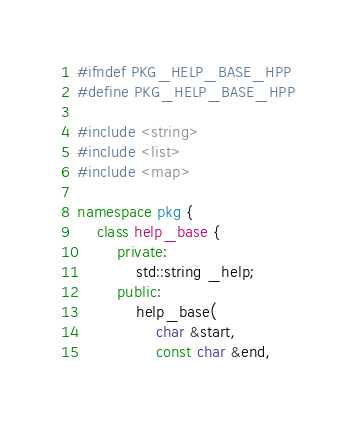Convert code to text. <code><loc_0><loc_0><loc_500><loc_500><_C++_>#ifndef PKG_HELP_BASE_HPP
#define PKG_HELP_BASE_HPP

#include <string>
#include <list>
#include <map>

namespace pkg {
    class help_base {
        private:
            std::string _help;
        public:
            help_base(
                char &start, 
                const char &end, </code> 